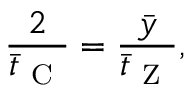<formula> <loc_0><loc_0><loc_500><loc_500>\frac { 2 } { \bar { t } _ { C } } = \frac { \bar { y } } { \bar { t } _ { Z } } ,</formula> 